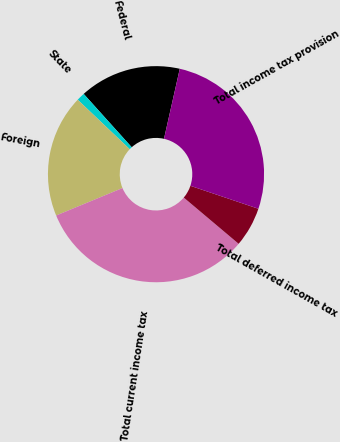Convert chart. <chart><loc_0><loc_0><loc_500><loc_500><pie_chart><fcel>Federal<fcel>State<fcel>Foreign<fcel>Total current income tax<fcel>Total deferred income tax<fcel>Total income tax provision<nl><fcel>15.2%<fcel>1.23%<fcel>18.34%<fcel>32.61%<fcel>5.96%<fcel>26.65%<nl></chart> 